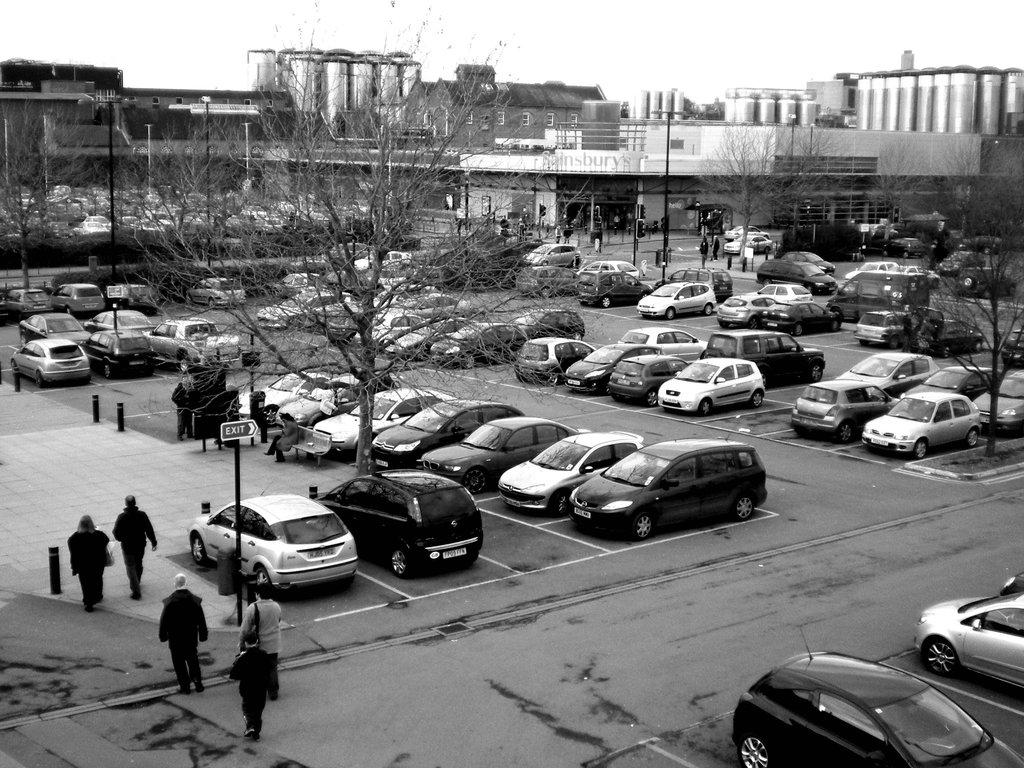What can be seen in the image related to transportation? There are cars parked in one place in the image. What are the people in the image doing? There are people walking in the image. What type of natural elements can be seen in the image? There are trees visible in the image. What type of man-made structures can be seen in the image? There are buildings in the image. Can you see any blood on the trees in the image? There is no blood present on the trees in the image. What type of sticks are the people using to walk in the image? There are no sticks visible in the image; the people are walking without any walking aids. 